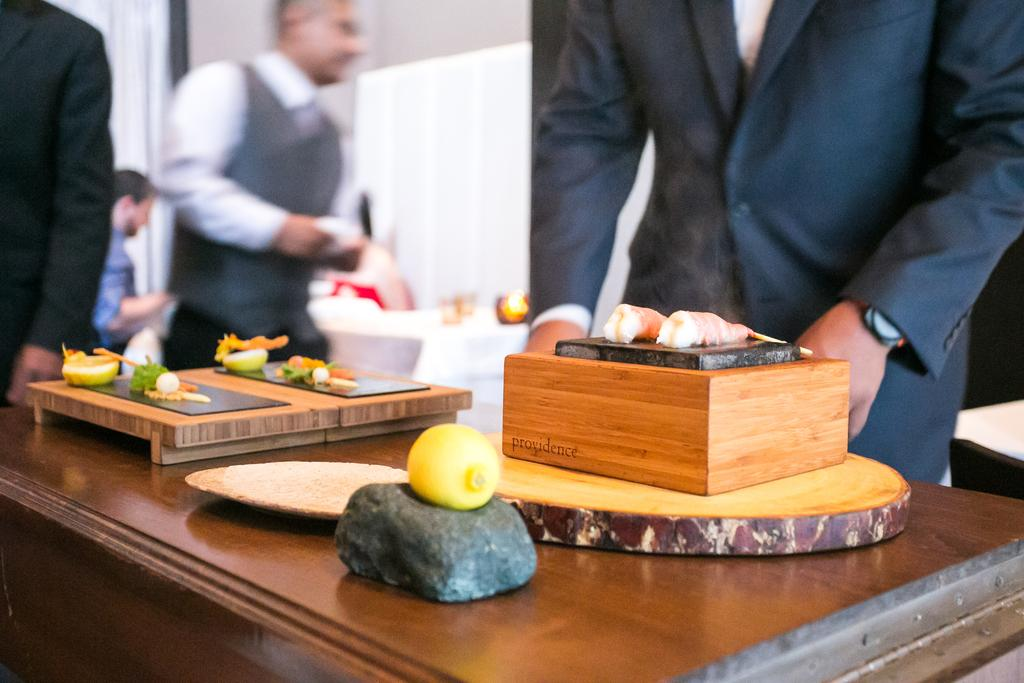What is the primary setting of the image? The primary setting of the image is a table with objects on it. Can you describe the objects on the table? Unfortunately, the provided facts do not specify the objects on the table. What is happening in the background of the image? There are people standing in the background of the image. How many letters are being shown to the people in the background? There is no mention of letters in the image, so we cannot determine if any are being shown to the people in the background. 